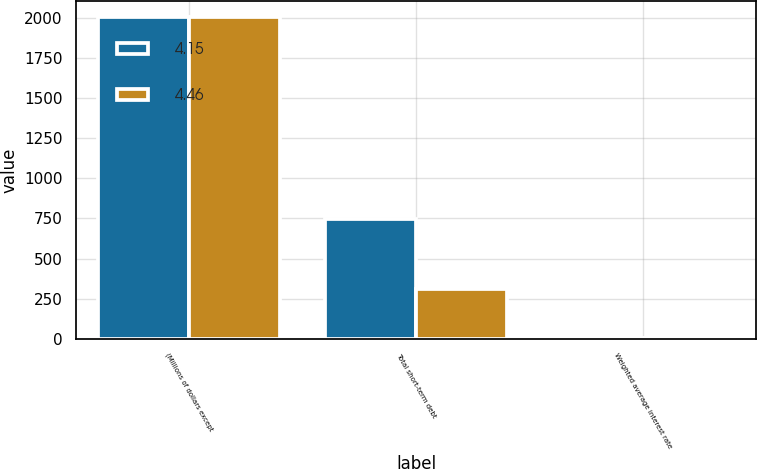<chart> <loc_0><loc_0><loc_500><loc_500><stacked_bar_chart><ecel><fcel>(Millions of dollars except<fcel>Total short-term debt<fcel>Weighted average interest rate<nl><fcel>4.15<fcel>2005<fcel>746.1<fcel>4.46<nl><fcel>4.46<fcel>2004<fcel>312.3<fcel>4.15<nl></chart> 